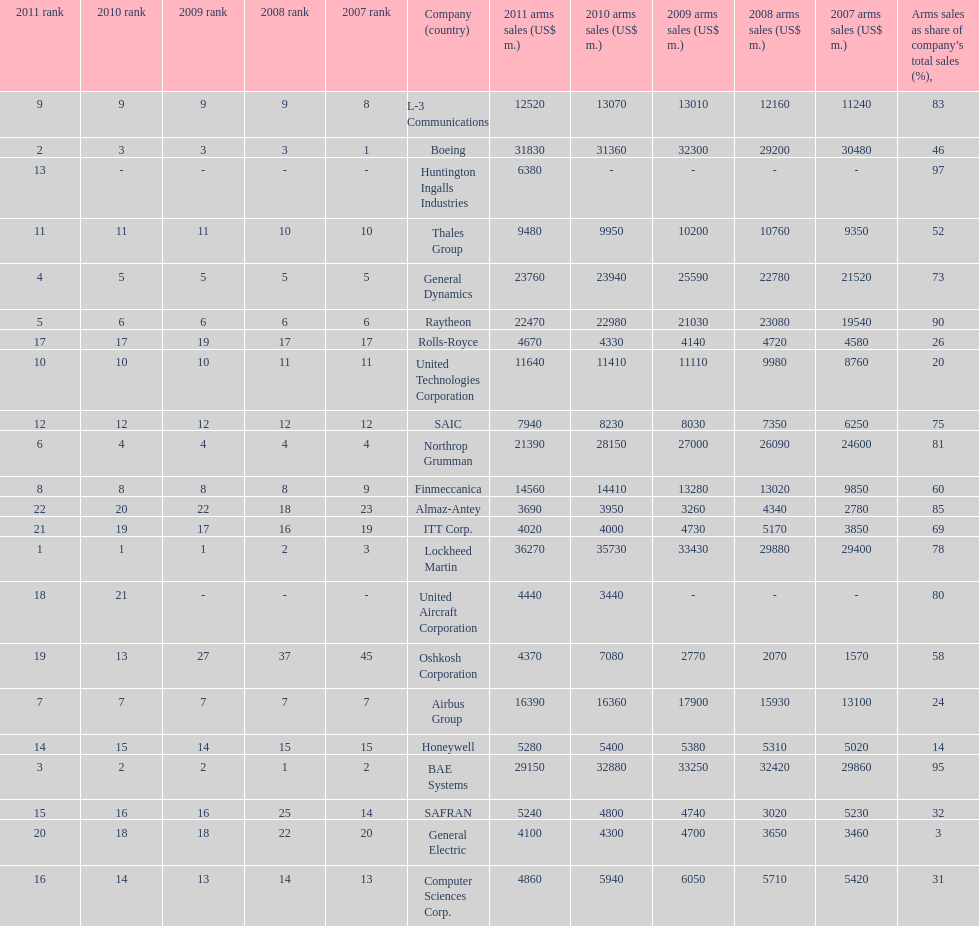Help me parse the entirety of this table. {'header': ['2011 rank', '2010 rank', '2009 rank', '2008 rank', '2007 rank', 'Company (country)', '2011 arms sales (US$ m.)', '2010 arms sales (US$ m.)', '2009 arms sales (US$ m.)', '2008 arms sales (US$ m.)', '2007 arms sales (US$ m.)', 'Arms sales as share of company’s total sales (%),'], 'rows': [['9', '9', '9', '9', '8', 'L-3 Communications', '12520', '13070', '13010', '12160', '11240', '83'], ['2', '3', '3', '3', '1', 'Boeing', '31830', '31360', '32300', '29200', '30480', '46'], ['13', '-', '-', '-', '-', 'Huntington Ingalls Industries', '6380', '-', '-', '-', '-', '97'], ['11', '11', '11', '10', '10', 'Thales Group', '9480', '9950', '10200', '10760', '9350', '52'], ['4', '5', '5', '5', '5', 'General Dynamics', '23760', '23940', '25590', '22780', '21520', '73'], ['5', '6', '6', '6', '6', 'Raytheon', '22470', '22980', '21030', '23080', '19540', '90'], ['17', '17', '19', '17', '17', 'Rolls-Royce', '4670', '4330', '4140', '4720', '4580', '26'], ['10', '10', '10', '11', '11', 'United Technologies Corporation', '11640', '11410', '11110', '9980', '8760', '20'], ['12', '12', '12', '12', '12', 'SAIC', '7940', '8230', '8030', '7350', '6250', '75'], ['6', '4', '4', '4', '4', 'Northrop Grumman', '21390', '28150', '27000', '26090', '24600', '81'], ['8', '8', '8', '8', '9', 'Finmeccanica', '14560', '14410', '13280', '13020', '9850', '60'], ['22', '20', '22', '18', '23', 'Almaz-Antey', '3690', '3950', '3260', '4340', '2780', '85'], ['21', '19', '17', '16', '19', 'ITT Corp.', '4020', '4000', '4730', '5170', '3850', '69'], ['1', '1', '1', '2', '3', 'Lockheed Martin', '36270', '35730', '33430', '29880', '29400', '78'], ['18', '21', '-', '-', '-', 'United Aircraft Corporation', '4440', '3440', '-', '-', '-', '80'], ['19', '13', '27', '37', '45', 'Oshkosh Corporation', '4370', '7080', '2770', '2070', '1570', '58'], ['7', '7', '7', '7', '7', 'Airbus Group', '16390', '16360', '17900', '15930', '13100', '24'], ['14', '15', '14', '15', '15', 'Honeywell', '5280', '5400', '5380', '5310', '5020', '14'], ['3', '2', '2', '1', '2', 'BAE Systems', '29150', '32880', '33250', '32420', '29860', '95'], ['15', '16', '16', '25', '14', 'SAFRAN', '5240', '4800', '4740', '3020', '5230', '32'], ['20', '18', '18', '22', '20', 'General Electric', '4100', '4300', '4700', '3650', '3460', '3'], ['16', '14', '13', '14', '13', 'Computer Sciences Corp.', '4860', '5940', '6050', '5710', '5420', '31']]} What country is the first listed country? USA. 